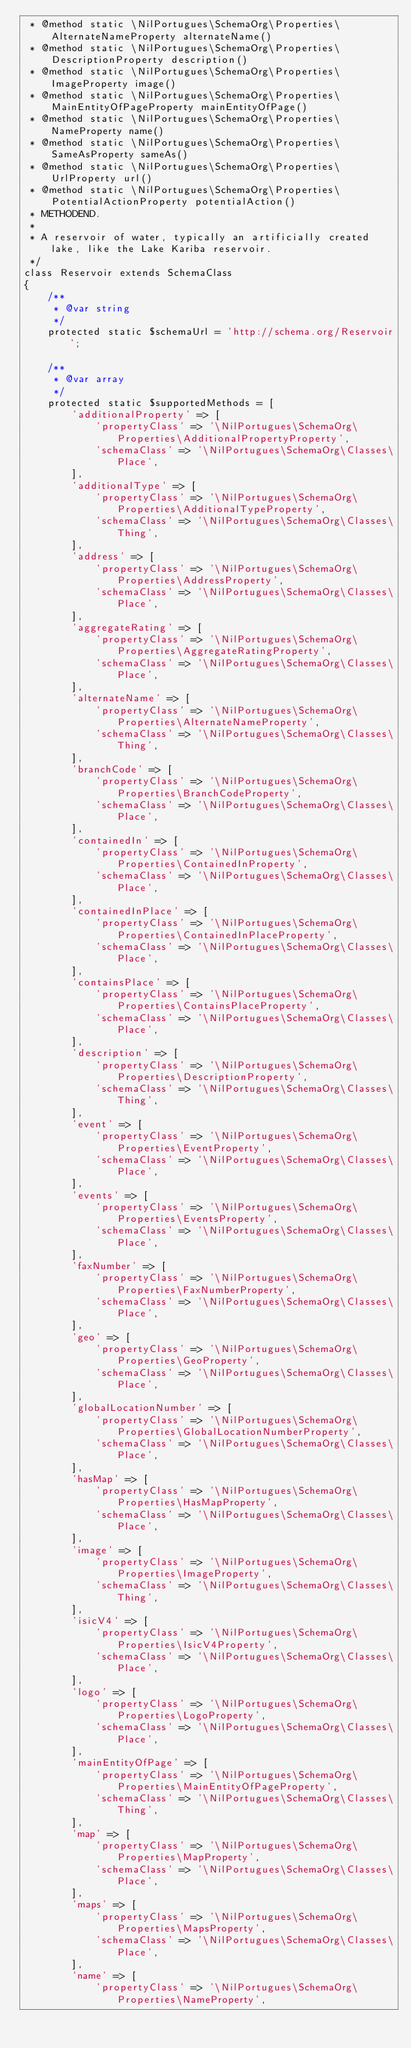<code> <loc_0><loc_0><loc_500><loc_500><_PHP_> * @method static \NilPortugues\SchemaOrg\Properties\AlternateNameProperty alternateName()
 * @method static \NilPortugues\SchemaOrg\Properties\DescriptionProperty description()
 * @method static \NilPortugues\SchemaOrg\Properties\ImageProperty image()
 * @method static \NilPortugues\SchemaOrg\Properties\MainEntityOfPageProperty mainEntityOfPage()
 * @method static \NilPortugues\SchemaOrg\Properties\NameProperty name()
 * @method static \NilPortugues\SchemaOrg\Properties\SameAsProperty sameAs()
 * @method static \NilPortugues\SchemaOrg\Properties\UrlProperty url()
 * @method static \NilPortugues\SchemaOrg\Properties\PotentialActionProperty potentialAction()
 * METHODEND.
 *
 * A reservoir of water, typically an artificially created lake, like the Lake Kariba reservoir.
 */
class Reservoir extends SchemaClass
{
    /**
     * @var string
     */
    protected static $schemaUrl = 'http://schema.org/Reservoir';

    /**
     * @var array
     */
    protected static $supportedMethods = [
        'additionalProperty' => [
            'propertyClass' => '\NilPortugues\SchemaOrg\Properties\AdditionalPropertyProperty',
            'schemaClass' => '\NilPortugues\SchemaOrg\Classes\Place',
        ],
        'additionalType' => [
            'propertyClass' => '\NilPortugues\SchemaOrg\Properties\AdditionalTypeProperty',
            'schemaClass' => '\NilPortugues\SchemaOrg\Classes\Thing',
        ],
        'address' => [
            'propertyClass' => '\NilPortugues\SchemaOrg\Properties\AddressProperty',
            'schemaClass' => '\NilPortugues\SchemaOrg\Classes\Place',
        ],
        'aggregateRating' => [
            'propertyClass' => '\NilPortugues\SchemaOrg\Properties\AggregateRatingProperty',
            'schemaClass' => '\NilPortugues\SchemaOrg\Classes\Place',
        ],
        'alternateName' => [
            'propertyClass' => '\NilPortugues\SchemaOrg\Properties\AlternateNameProperty',
            'schemaClass' => '\NilPortugues\SchemaOrg\Classes\Thing',
        ],
        'branchCode' => [
            'propertyClass' => '\NilPortugues\SchemaOrg\Properties\BranchCodeProperty',
            'schemaClass' => '\NilPortugues\SchemaOrg\Classes\Place',
        ],
        'containedIn' => [
            'propertyClass' => '\NilPortugues\SchemaOrg\Properties\ContainedInProperty',
            'schemaClass' => '\NilPortugues\SchemaOrg\Classes\Place',
        ],
        'containedInPlace' => [
            'propertyClass' => '\NilPortugues\SchemaOrg\Properties\ContainedInPlaceProperty',
            'schemaClass' => '\NilPortugues\SchemaOrg\Classes\Place',
        ],
        'containsPlace' => [
            'propertyClass' => '\NilPortugues\SchemaOrg\Properties\ContainsPlaceProperty',
            'schemaClass' => '\NilPortugues\SchemaOrg\Classes\Place',
        ],
        'description' => [
            'propertyClass' => '\NilPortugues\SchemaOrg\Properties\DescriptionProperty',
            'schemaClass' => '\NilPortugues\SchemaOrg\Classes\Thing',
        ],
        'event' => [
            'propertyClass' => '\NilPortugues\SchemaOrg\Properties\EventProperty',
            'schemaClass' => '\NilPortugues\SchemaOrg\Classes\Place',
        ],
        'events' => [
            'propertyClass' => '\NilPortugues\SchemaOrg\Properties\EventsProperty',
            'schemaClass' => '\NilPortugues\SchemaOrg\Classes\Place',
        ],
        'faxNumber' => [
            'propertyClass' => '\NilPortugues\SchemaOrg\Properties\FaxNumberProperty',
            'schemaClass' => '\NilPortugues\SchemaOrg\Classes\Place',
        ],
        'geo' => [
            'propertyClass' => '\NilPortugues\SchemaOrg\Properties\GeoProperty',
            'schemaClass' => '\NilPortugues\SchemaOrg\Classes\Place',
        ],
        'globalLocationNumber' => [
            'propertyClass' => '\NilPortugues\SchemaOrg\Properties\GlobalLocationNumberProperty',
            'schemaClass' => '\NilPortugues\SchemaOrg\Classes\Place',
        ],
        'hasMap' => [
            'propertyClass' => '\NilPortugues\SchemaOrg\Properties\HasMapProperty',
            'schemaClass' => '\NilPortugues\SchemaOrg\Classes\Place',
        ],
        'image' => [
            'propertyClass' => '\NilPortugues\SchemaOrg\Properties\ImageProperty',
            'schemaClass' => '\NilPortugues\SchemaOrg\Classes\Thing',
        ],
        'isicV4' => [
            'propertyClass' => '\NilPortugues\SchemaOrg\Properties\IsicV4Property',
            'schemaClass' => '\NilPortugues\SchemaOrg\Classes\Place',
        ],
        'logo' => [
            'propertyClass' => '\NilPortugues\SchemaOrg\Properties\LogoProperty',
            'schemaClass' => '\NilPortugues\SchemaOrg\Classes\Place',
        ],
        'mainEntityOfPage' => [
            'propertyClass' => '\NilPortugues\SchemaOrg\Properties\MainEntityOfPageProperty',
            'schemaClass' => '\NilPortugues\SchemaOrg\Classes\Thing',
        ],
        'map' => [
            'propertyClass' => '\NilPortugues\SchemaOrg\Properties\MapProperty',
            'schemaClass' => '\NilPortugues\SchemaOrg\Classes\Place',
        ],
        'maps' => [
            'propertyClass' => '\NilPortugues\SchemaOrg\Properties\MapsProperty',
            'schemaClass' => '\NilPortugues\SchemaOrg\Classes\Place',
        ],
        'name' => [
            'propertyClass' => '\NilPortugues\SchemaOrg\Properties\NameProperty',</code> 